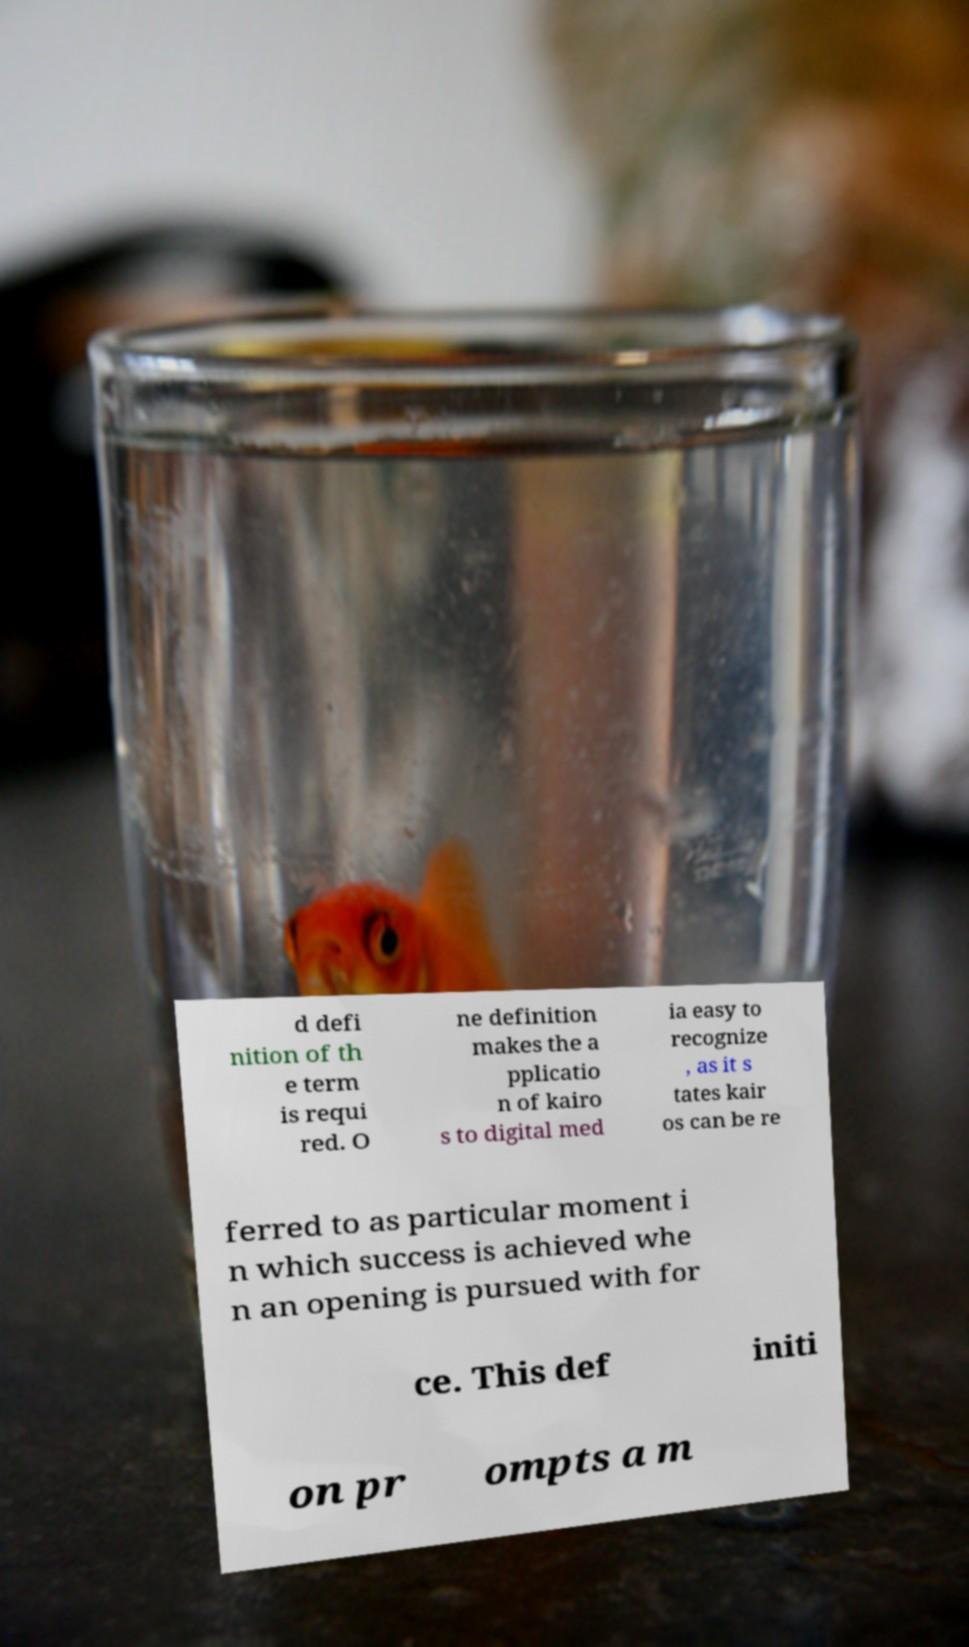Please read and relay the text visible in this image. What does it say? d defi nition of th e term is requi red. O ne definition makes the a pplicatio n of kairo s to digital med ia easy to recognize , as it s tates kair os can be re ferred to as particular moment i n which success is achieved whe n an opening is pursued with for ce. This def initi on pr ompts a m 